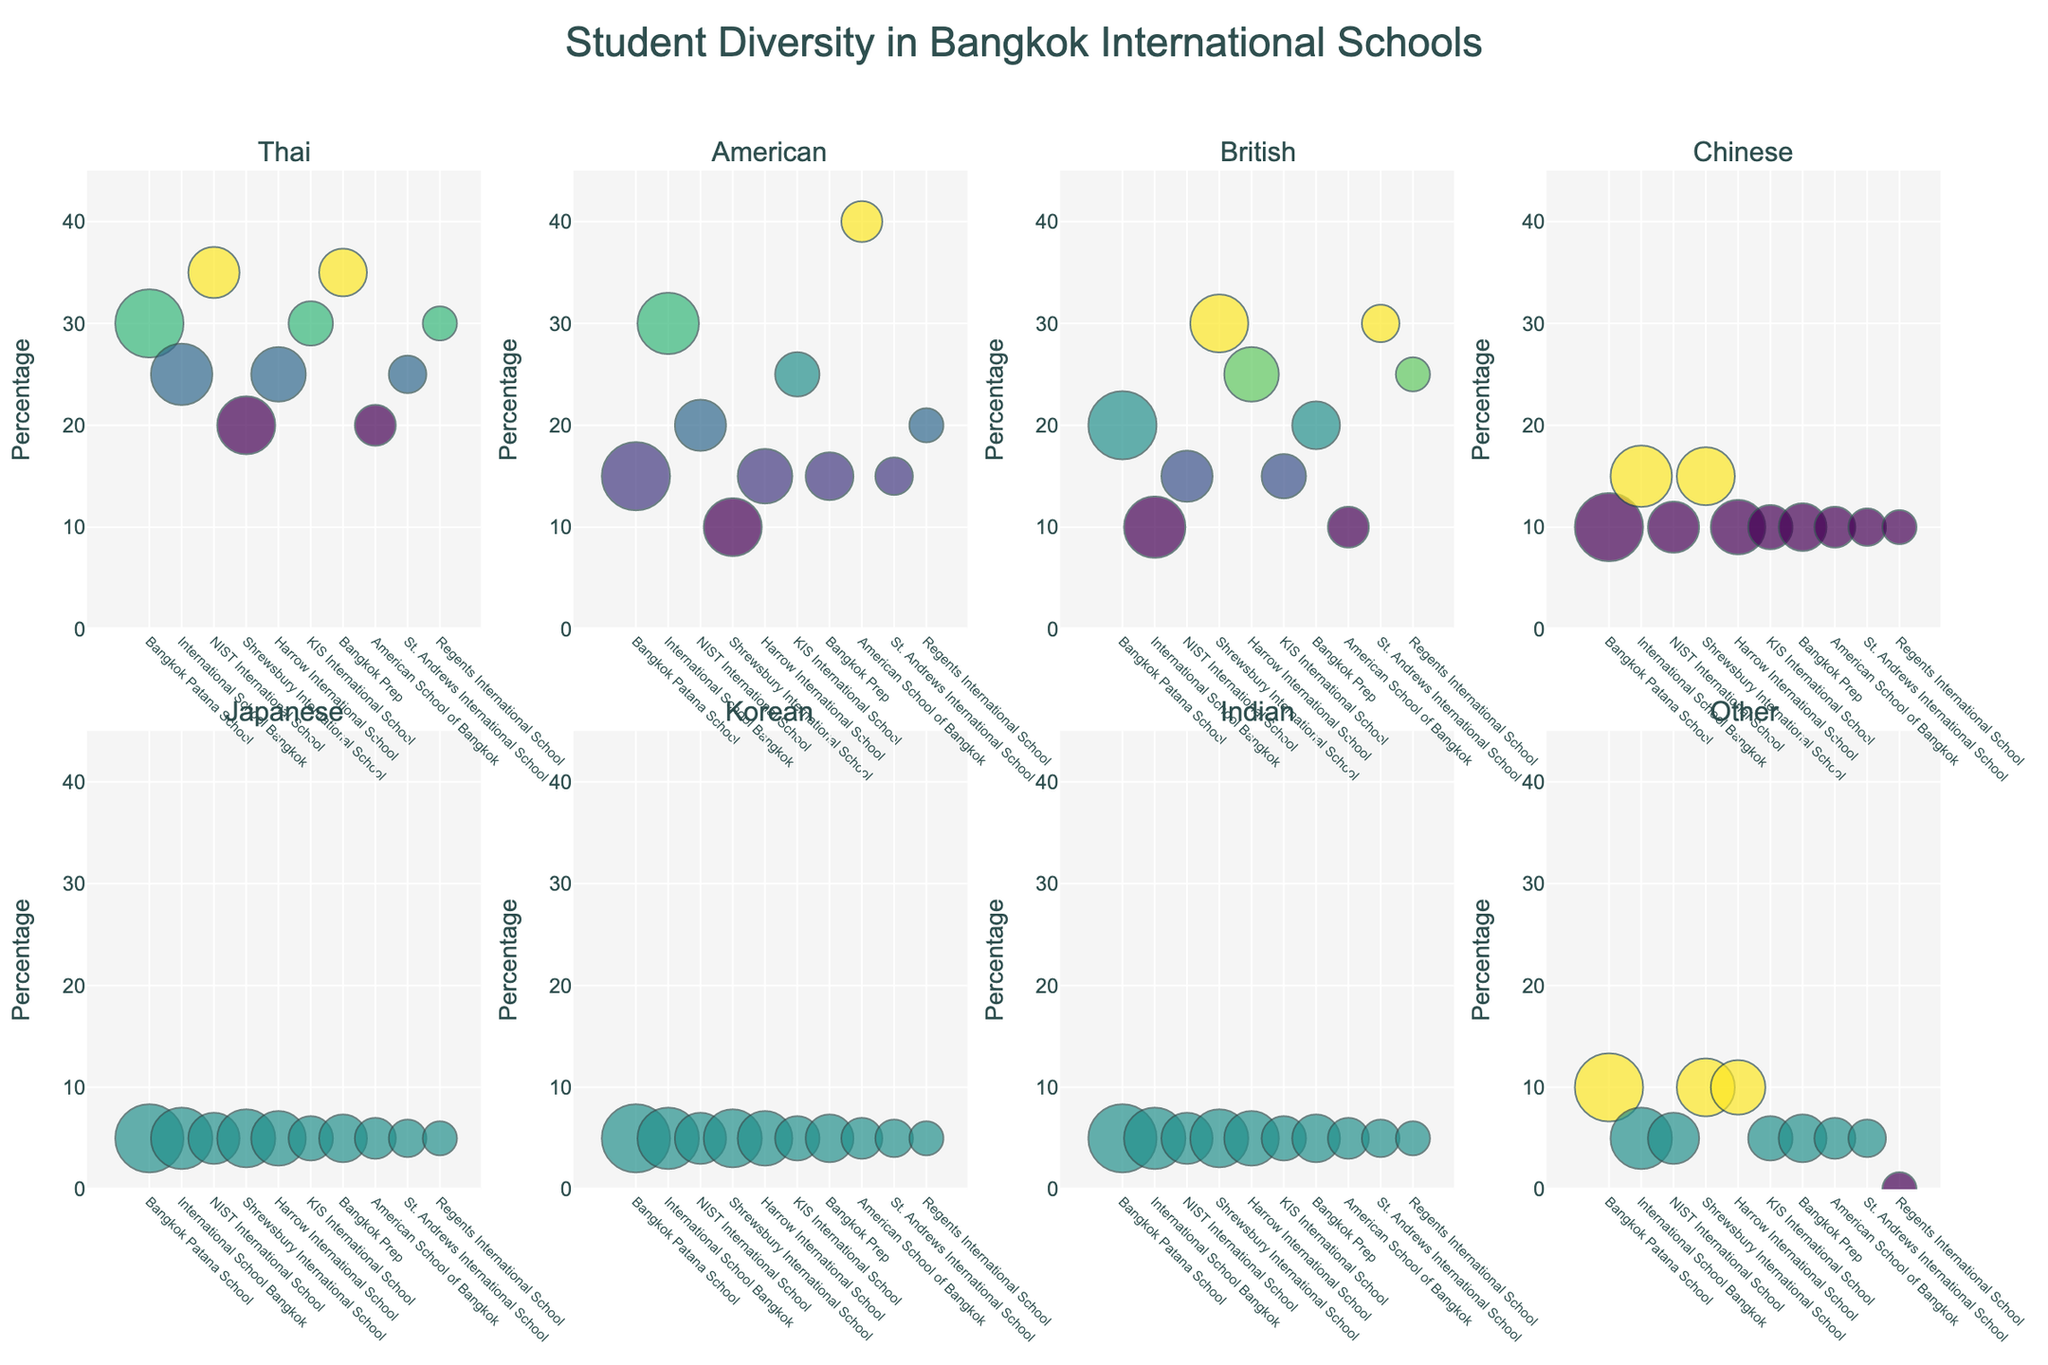Do any schools have the same percentage of American students? The percentage of American students needs to be compared across different schools. By referring to the subplot for American students, we see that both International School Bangkok and American School of Bangkok have 40% American students.
Answer: Yes, International School Bangkok and American School of Bangkok Which school has the highest percentage of Thai students? To find the school with the highest percentage of Thai students, we look at the subplot for Thai students. Here, Bangkok Prep and NIST International School have the highest percentage, both at 35%.
Answer: Bangkok Prep and NIST International School Which school has the smallest bubble size, and which nationality does it represent? To determine the school with the smallest bubble size, we need to look across all subplots and find the bubble with the least size. Regents International School has the smallest bubble which represents 'Other' nationalities.
Answer: Regents International School with 'Other' What is the total student population for Shrewsbury International School? Referring to any of the subplots, we can see from the bubble size (or hover text) of Shrewsbury International School which indicates the total student population. The bubble size points to a total population of 1700 students.
Answer: 1700 How many schools have more than 25% British students? Checking the subplot for British students, we find that Shrewsbury International School, Harrow International School, and St. Andrews International School have more than 25% British students.
Answer: Three schools Which nationality has the highest percentage at American School of Bangkok? Inspecting the subplot that shows the American School of Bangkok, the nationality with the highest percentage is American with 40%.
Answer: American Is the percentage of Chinese students greater at International School Bangkok or KIS International School? Comparing the percentage of Chinese students between International School Bangkok (15%) and KIS International School (10%) in the respective subplot, International School Bangkok has a higher percentage.
Answer: International School Bangkok What is the median percentage of American students across all schools? To calculate the median, we need to list the American students percentage: [40, 30, 25, 20, 15, 15, 15, 15, 15, 10], the middle value(s) after sorting this list will give us the median. Since there are 10 values, the average of the 5th and 6th values is median, which is (15 + 15)/2 = 15.
Answer: 15 Which school has the most diverse nationalities based on the bubble sizes? To determine the most diverse school, we examine the relative sizes of bubbles across all subplots for each school. Bangkok Patana School shows a balanced distribution among Thai, American, British, Other, and smaller yet represented nationalities, indicating a high diversity.
Answer: Bangkok Patana School 